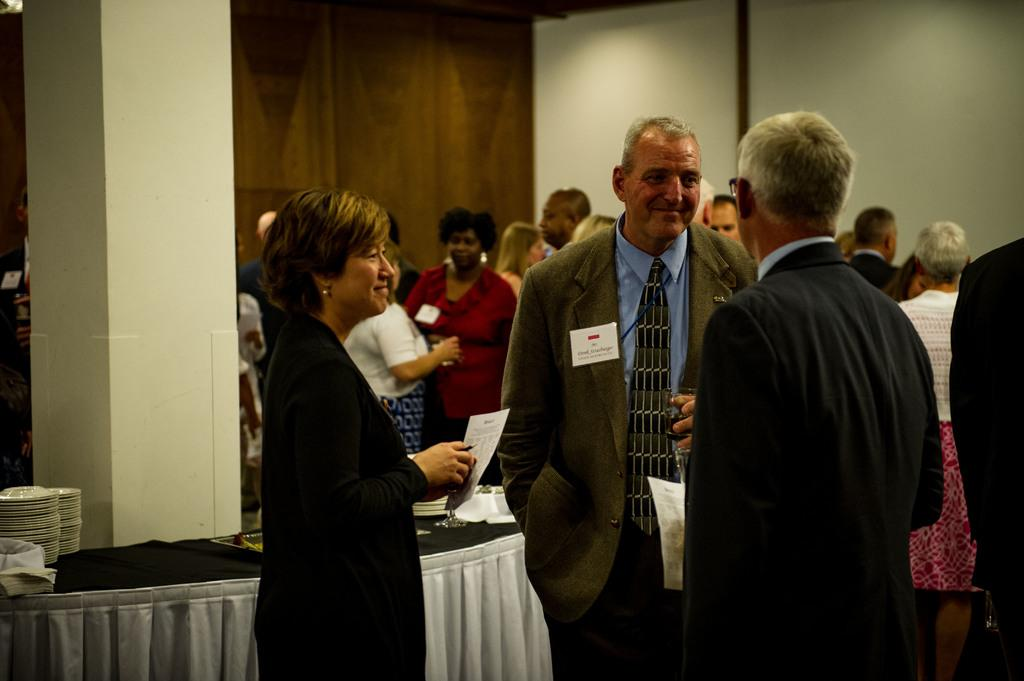What can be seen in the image involving people? There are people standing in the image. What objects are present in the image related to food or dining? There are plates in the image. What type of structure is visible in the background? There is a wall in the image. What type of potato is being served on the plates in the image? There is no potato visible on the plates in the image. How does the rock contribute to the society depicted in the image? There is no rock or society present in the image. 